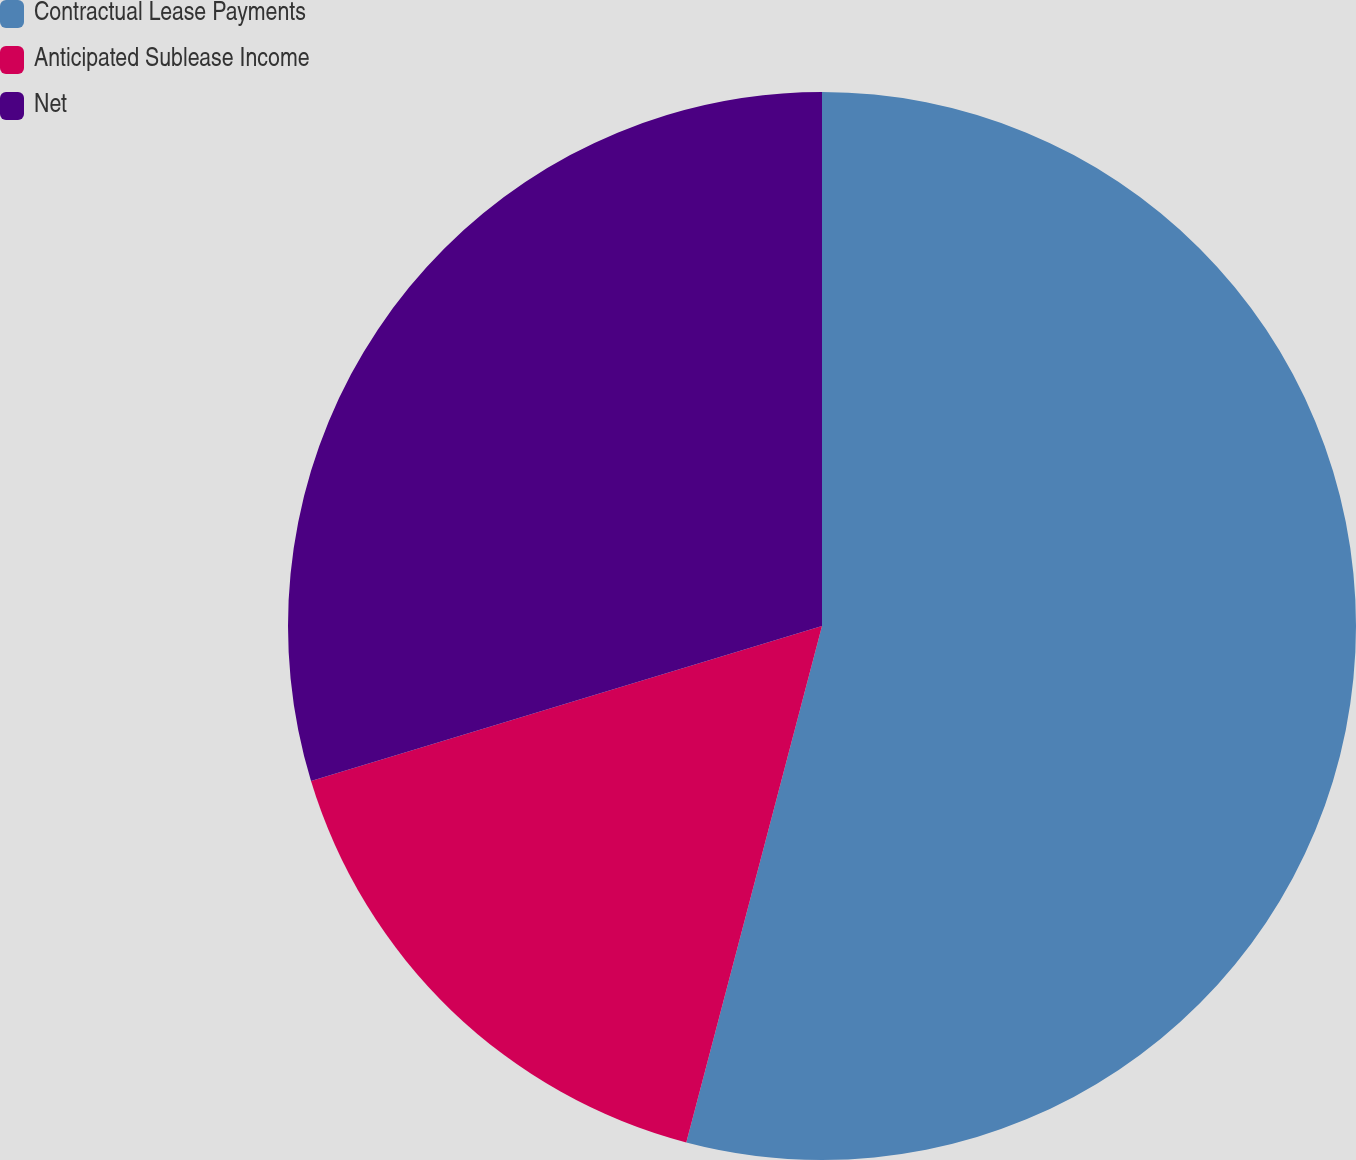Convert chart. <chart><loc_0><loc_0><loc_500><loc_500><pie_chart><fcel>Contractual Lease Payments<fcel>Anticipated Sublease Income<fcel>Net<nl><fcel>54.09%<fcel>16.22%<fcel>29.69%<nl></chart> 